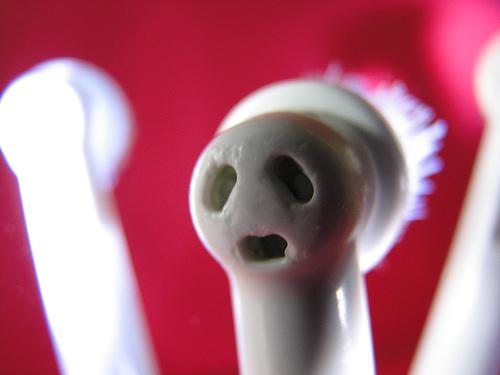How many toothbrushes are present in the image and describe their positioning briefly? There are two toothbrushes in the image; one is a white electric toothbrush in focus, and the other is a blurry, white object positioned to the left. Examine the three oblong holes in the brush and provide a brief description of their arrangement. The three oblong holes in the brush are situated close together and are vertically aligned, giving a slight impression of a face with two eyes and a mouth. Give a short description of the interaction between the objects in this image. The electric toothbrush with a round head and bristles is in the foreground and focus, while another blurry toothbrush is positioned to the left, serving as a supporting element. Assess the overall quality of the image, considering factors such as focus, lighting, and composition. The image is of high quality, with a clear focus on the electric toothbrush, effective use of lighting to create reflections and shadows, and a well-balanced composition with the main subject at the center. Discuss the impact of lighting in this image and how it accentuates certain characteristics of the objects. The lighting creates interesting effects such as the reflection on the toothbrush's side, the blade of reflection, and the shadows to the right of the brush, which emphasize its form and contribute to the overall polished appearance. Identify the primary object in the image and provide a brief description of its appearance. The primary object is an electric toothbrush featuring a white, round head with bristles that have a blue tint at the tips, and an oval opening with some chips around it. Considering all objects present in the image, can you count how many items have a white or off-white color? There are six items with white or off-white color: the electric toothbrush, the round bristles, the oval hole with chips, the off-white spin brush head, the blurry white object, and the white brush on the right side. What is the color of the background, and can you identify any specific features related to it? The background is lipstick red, with a red cloth behind the brushes. Briefly describe the sentiment or mood conveyed by this image. The image conveys a clean, polished mood, emphasizing the efficiency and quality of the electric toothbrush against a bright red background. 